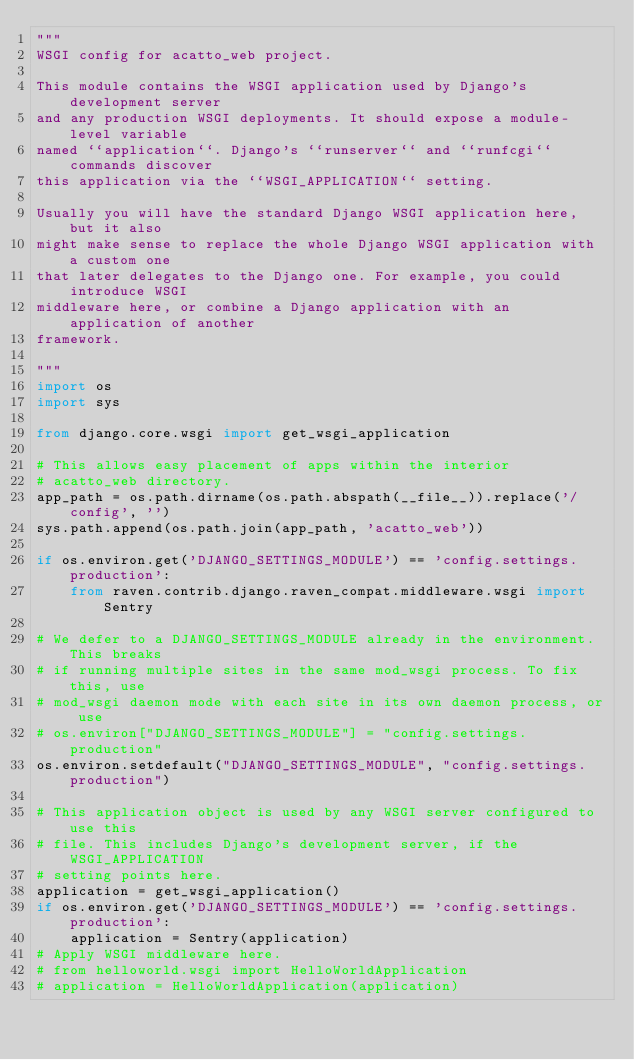Convert code to text. <code><loc_0><loc_0><loc_500><loc_500><_Python_>"""
WSGI config for acatto_web project.

This module contains the WSGI application used by Django's development server
and any production WSGI deployments. It should expose a module-level variable
named ``application``. Django's ``runserver`` and ``runfcgi`` commands discover
this application via the ``WSGI_APPLICATION`` setting.

Usually you will have the standard Django WSGI application here, but it also
might make sense to replace the whole Django WSGI application with a custom one
that later delegates to the Django one. For example, you could introduce WSGI
middleware here, or combine a Django application with an application of another
framework.

"""
import os
import sys

from django.core.wsgi import get_wsgi_application

# This allows easy placement of apps within the interior
# acatto_web directory.
app_path = os.path.dirname(os.path.abspath(__file__)).replace('/config', '')
sys.path.append(os.path.join(app_path, 'acatto_web'))

if os.environ.get('DJANGO_SETTINGS_MODULE') == 'config.settings.production':
    from raven.contrib.django.raven_compat.middleware.wsgi import Sentry

# We defer to a DJANGO_SETTINGS_MODULE already in the environment. This breaks
# if running multiple sites in the same mod_wsgi process. To fix this, use
# mod_wsgi daemon mode with each site in its own daemon process, or use
# os.environ["DJANGO_SETTINGS_MODULE"] = "config.settings.production"
os.environ.setdefault("DJANGO_SETTINGS_MODULE", "config.settings.production")

# This application object is used by any WSGI server configured to use this
# file. This includes Django's development server, if the WSGI_APPLICATION
# setting points here.
application = get_wsgi_application()
if os.environ.get('DJANGO_SETTINGS_MODULE') == 'config.settings.production':
    application = Sentry(application)
# Apply WSGI middleware here.
# from helloworld.wsgi import HelloWorldApplication
# application = HelloWorldApplication(application)
</code> 